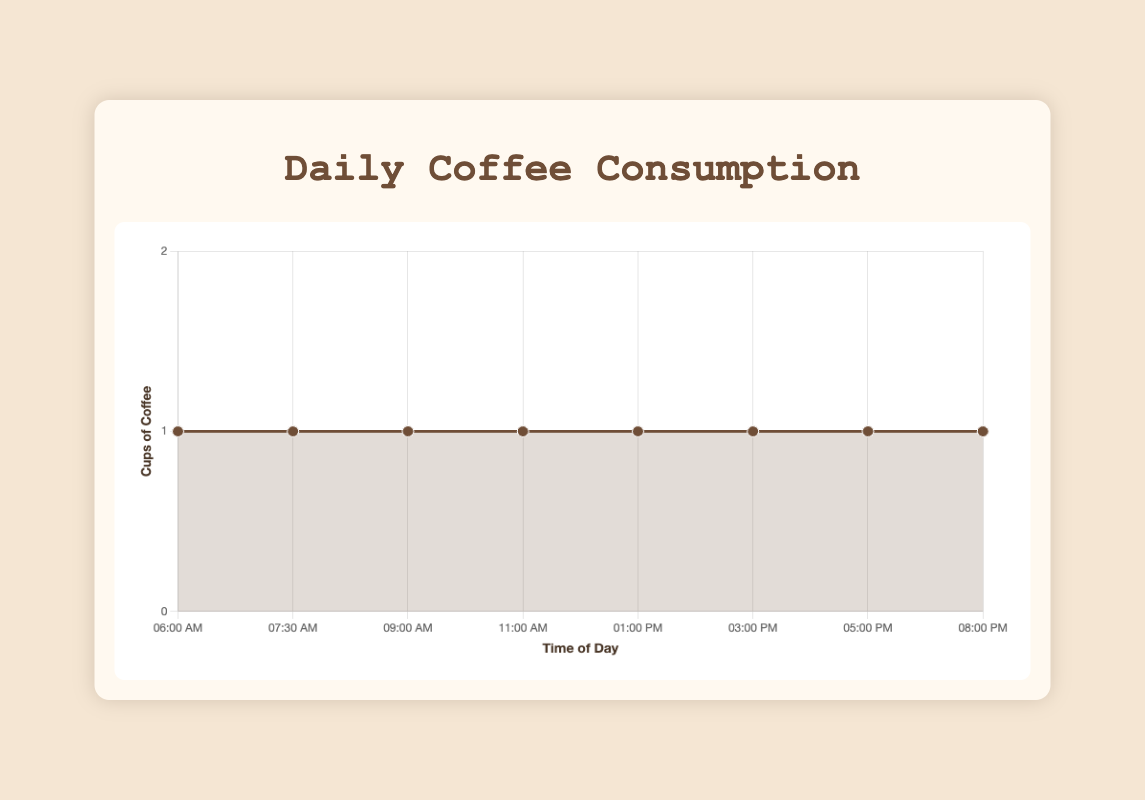What time of day does the coffee drinking start? We see from the line chart that the first coffee is consumed at 6:00 AM.
Answer: 06:00 AM How many cups of coffee are consumed by 11:00 AM? To find out how many cups of coffee are consumed by 11:00 AM, we add the values for 06:00 AM, 07:30 AM, 09:00 AM, and 11:00 AM (1 + 1 + 1 + 1).
Answer: 4 cups Do you drink the same amount of coffee in the afternoon as in the morning? In the morning (06:00 AM - 11:00 AM), 4 cups are consumed. In the afternoon (01:00 PM - 03:00 PM), 2 cups are consumed. The amounts differ.
Answer: No Which time of day has the least probability of coffee consumption? As each point in the chart shows 1 cup of coffee, there is no time of day with less coffee consumption than another.
Answer: None, all are equal Between which two consecutive times of day is the longest gap in coffee consumption? From the chart, the sequence of times is followed. The gap between 05:00 PM and 08:00 PM is the longest, a span of 3 hours.
Answer: 05:00 PM and 08:00 PM Is there any increase or decrease in coffee consumption throughout the day? According to the line chart, the coffee consumption is steady throughout the day, with no increase or decrease.
Answer: Steady What is described for the coffee consumed at 05:00 PM? Referring to the tooltip description, coffee consumed at 05:00 PM is for "Pre-evening wind down."
Answer: "Pre-evening wind down" How many total cups of coffee are consumed in a day? By adding all the cups of coffee consumed at different times of the day (1+1+1+1+1+1+1+1), we conclude 8 cups.
Answer: 8 cups What is the color of the line indicating coffee consumption on the chart? The line indicating coffee consumption is described as being of the color '#6F4E37', which is brown.
Answer: Brown 